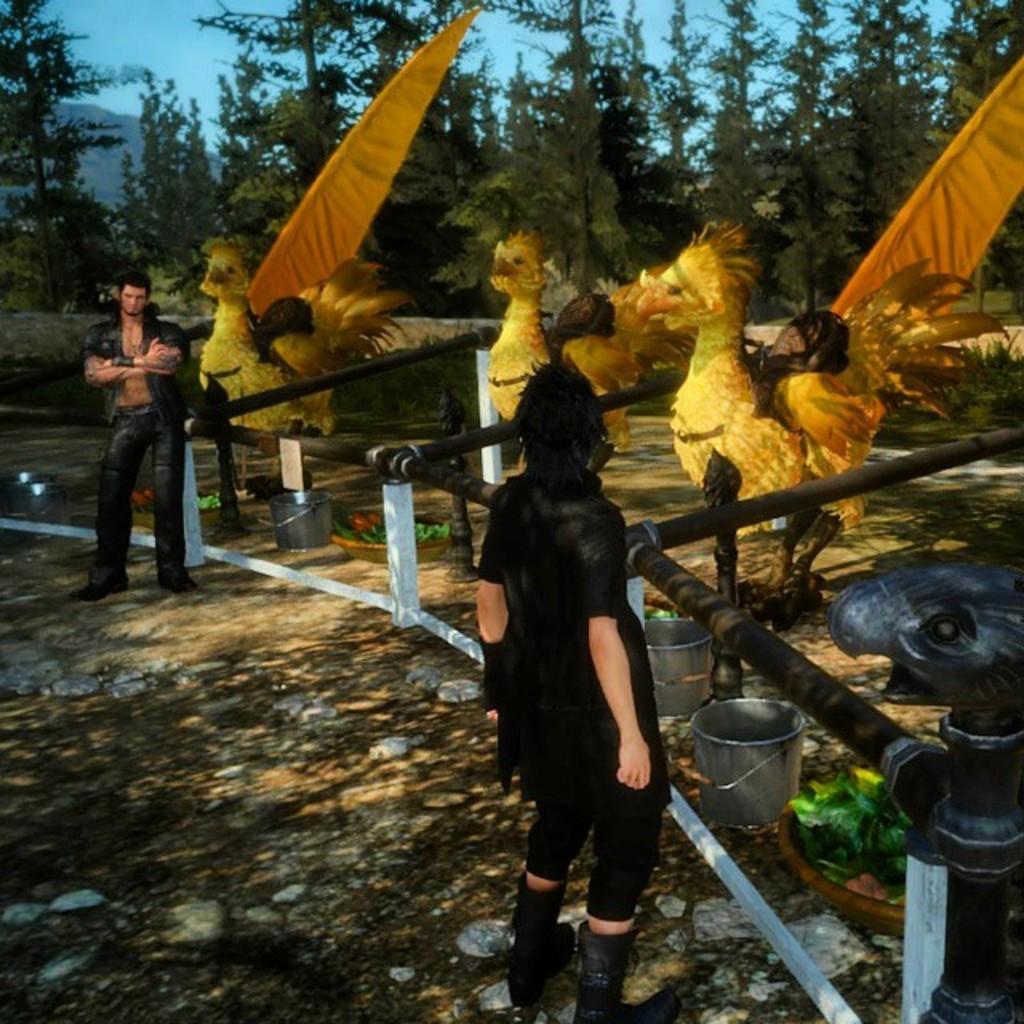Please provide a concise description of this image. In this picture I can see animation of people and animals. I can also see a fence, trees and the sky. In the background I can also see buckets, plants and other objects on the ground. 